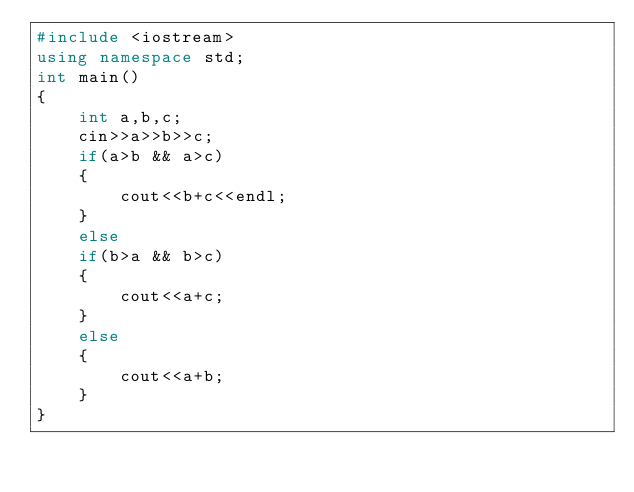<code> <loc_0><loc_0><loc_500><loc_500><_C++_>#include <iostream>
using namespace std;
int main()
{
    int a,b,c;
    cin>>a>>b>>c;
    if(a>b && a>c)
    {
        cout<<b+c<<endl;
    }
    else
    if(b>a && b>c)
    {
        cout<<a+c;
    }
    else
    {
        cout<<a+b;
    }
}
</code> 